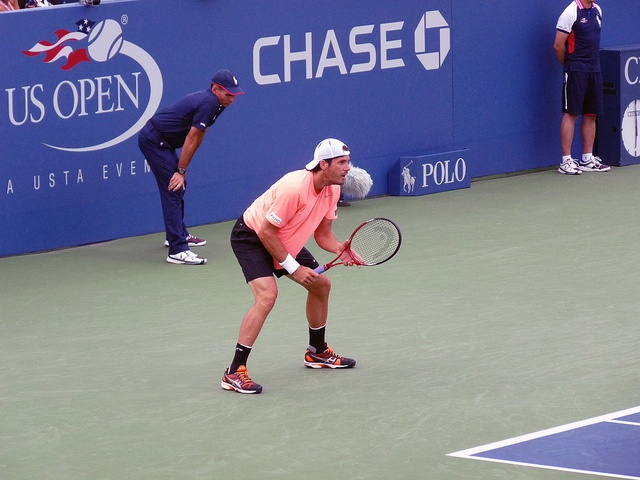Describe the objects in this image and their specific colors. I can see people in purple, black, lightpink, white, and darkgray tones, people in purple, navy, black, and blue tones, people in purple, black, navy, brown, and lavender tones, tennis racket in purple, darkgray, gray, brown, and black tones, and people in black, brown, maroon, lightpink, and salmon tones in this image. 